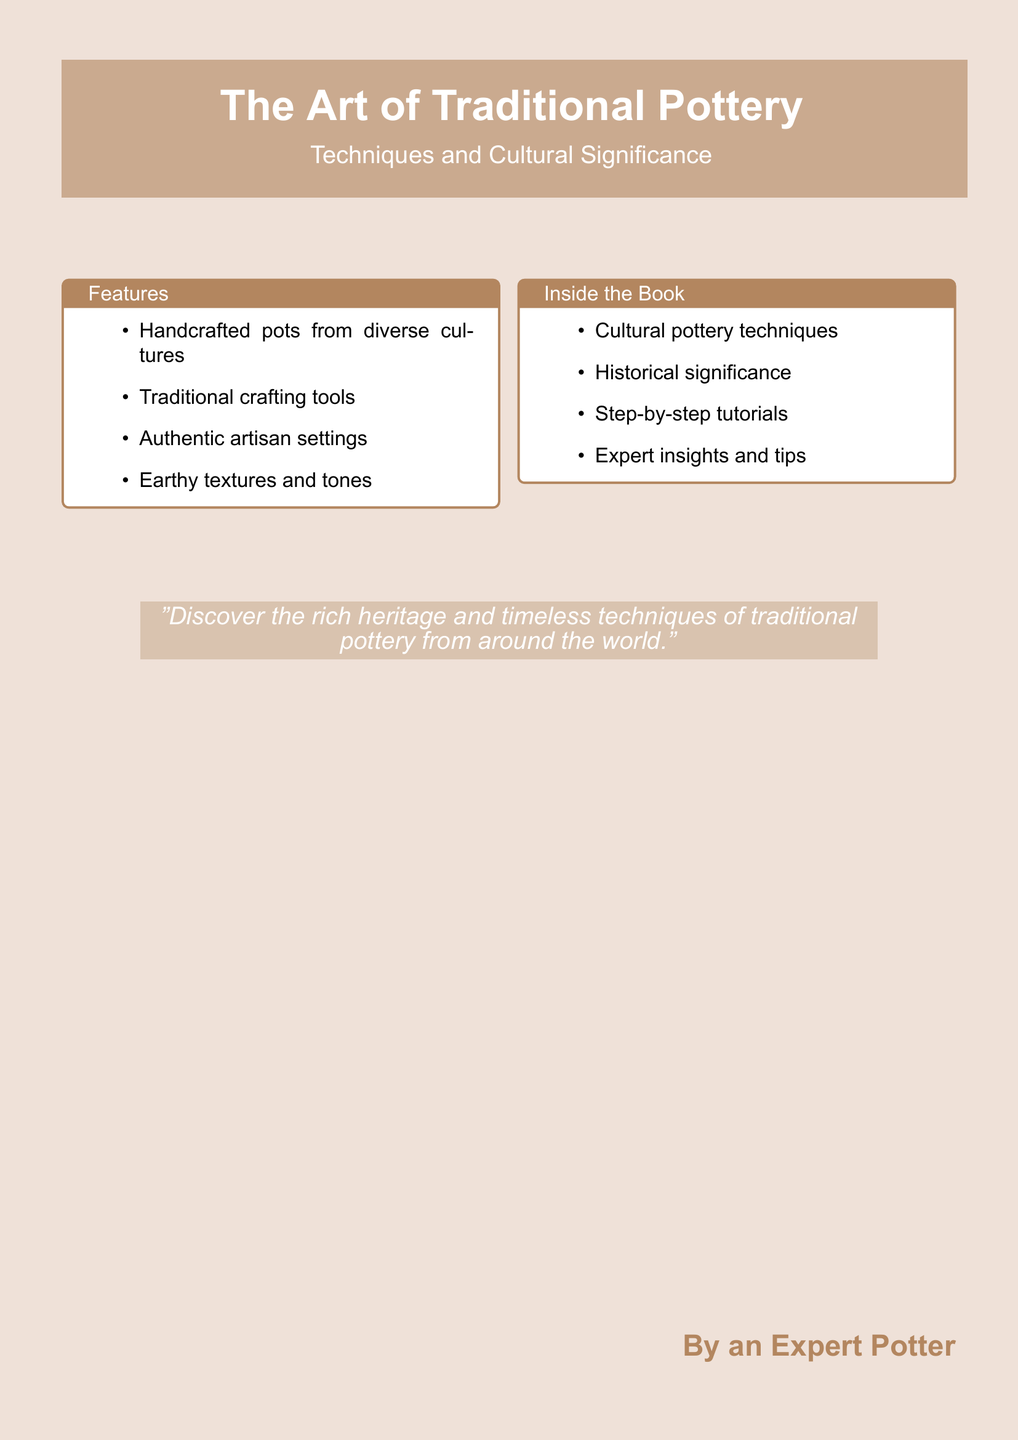What is the title of the book? The title is prominently displayed at the center of the cover design.
Answer: The Art of Traditional Pottery Who is the author of the book? The author's name is indicated at the bottom right of the cover.
Answer: By an Expert Potter What color is used for the earthy background? The earthy background is created using a specific color code referenced in the design.
Answer: Earthy What is the subtitle of the book? The subtitle is located below the main title, providing additional context about the book.
Answer: Techniques and Cultural Significance What type of techniques are covered in the book? The features section specifies the focus of the book, highlighting the content offered.
Answer: Cultural pottery techniques How many features are listed in the features section? The features section contains a bullet-point list that can be counted for clarity.
Answer: Four What is the main theme of the quote on the cover? The quote encapsulates the essence of the book's focus on cultural aspects.
Answer: Heritage and techniques What type of visual elements are included in the book's features? The features section describes the visual content that is significant to the book's narrative.
Answer: Handcrafted pots What type of crafting tools are emphasized in the book? The features section outlines important items relevant to the theme of pottery making.
Answer: Traditional crafting tools 